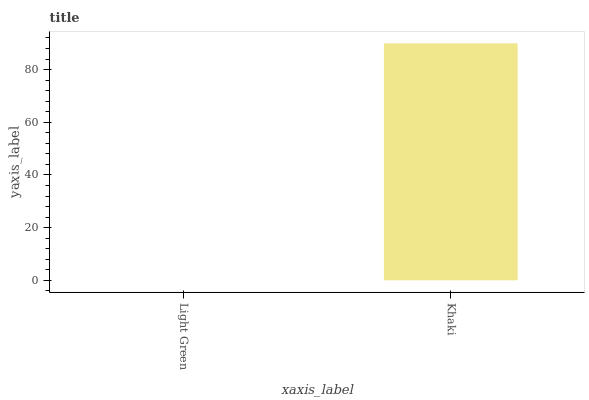Is Light Green the minimum?
Answer yes or no. Yes. Is Khaki the maximum?
Answer yes or no. Yes. Is Khaki the minimum?
Answer yes or no. No. Is Khaki greater than Light Green?
Answer yes or no. Yes. Is Light Green less than Khaki?
Answer yes or no. Yes. Is Light Green greater than Khaki?
Answer yes or no. No. Is Khaki less than Light Green?
Answer yes or no. No. Is Khaki the high median?
Answer yes or no. Yes. Is Light Green the low median?
Answer yes or no. Yes. Is Light Green the high median?
Answer yes or no. No. Is Khaki the low median?
Answer yes or no. No. 